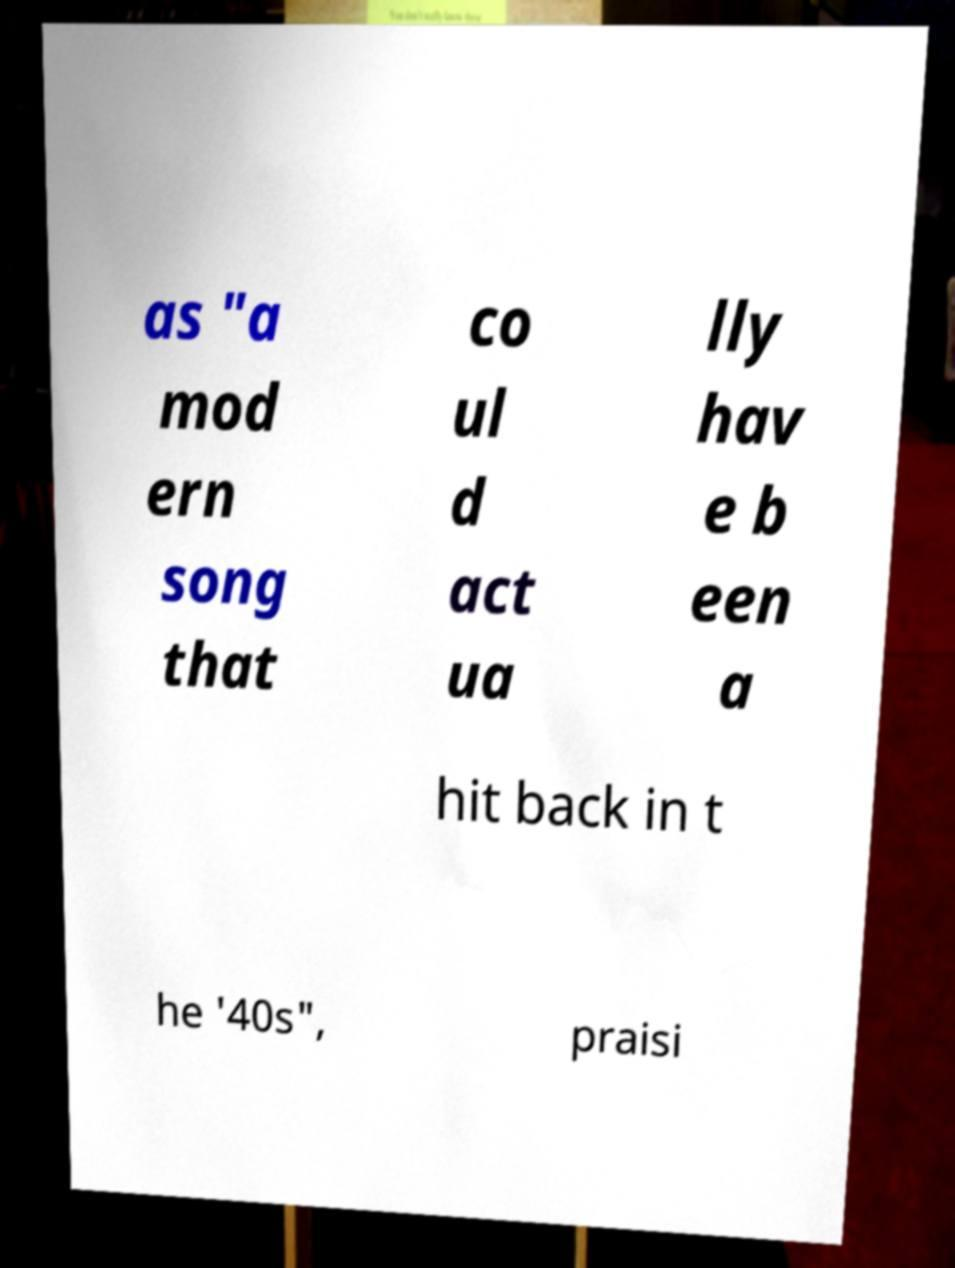Could you assist in decoding the text presented in this image and type it out clearly? as "a mod ern song that co ul d act ua lly hav e b een a hit back in t he '40s", praisi 